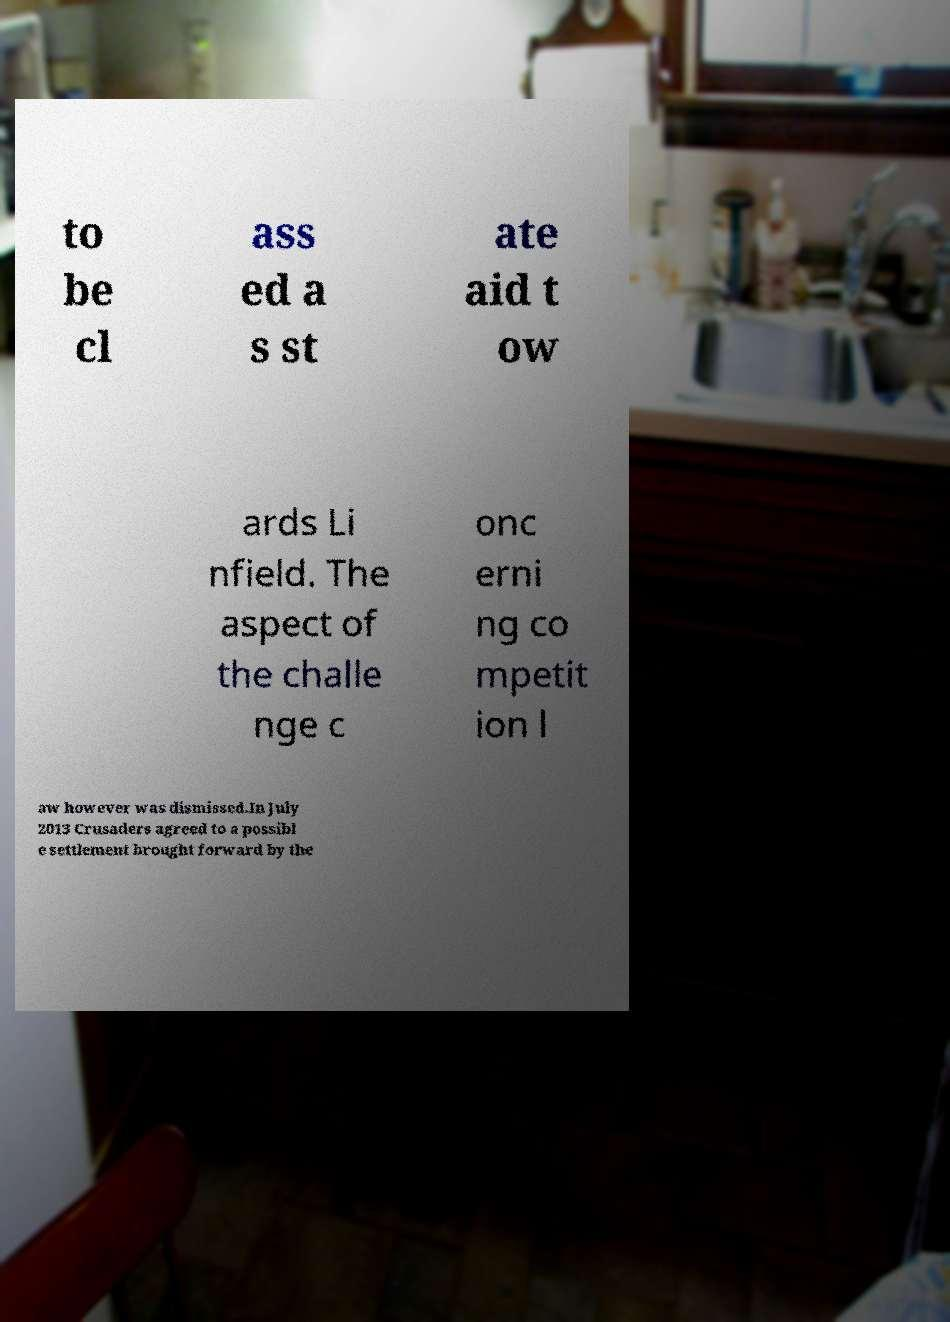I need the written content from this picture converted into text. Can you do that? to be cl ass ed a s st ate aid t ow ards Li nfield. The aspect of the challe nge c onc erni ng co mpetit ion l aw however was dismissed.In July 2013 Crusaders agreed to a possibl e settlement brought forward by the 